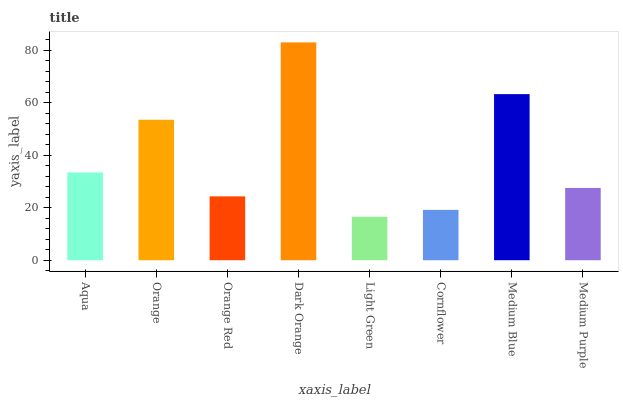Is Light Green the minimum?
Answer yes or no. Yes. Is Dark Orange the maximum?
Answer yes or no. Yes. Is Orange the minimum?
Answer yes or no. No. Is Orange the maximum?
Answer yes or no. No. Is Orange greater than Aqua?
Answer yes or no. Yes. Is Aqua less than Orange?
Answer yes or no. Yes. Is Aqua greater than Orange?
Answer yes or no. No. Is Orange less than Aqua?
Answer yes or no. No. Is Aqua the high median?
Answer yes or no. Yes. Is Medium Purple the low median?
Answer yes or no. Yes. Is Orange the high median?
Answer yes or no. No. Is Dark Orange the low median?
Answer yes or no. No. 